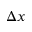<formula> <loc_0><loc_0><loc_500><loc_500>\Delta x</formula> 